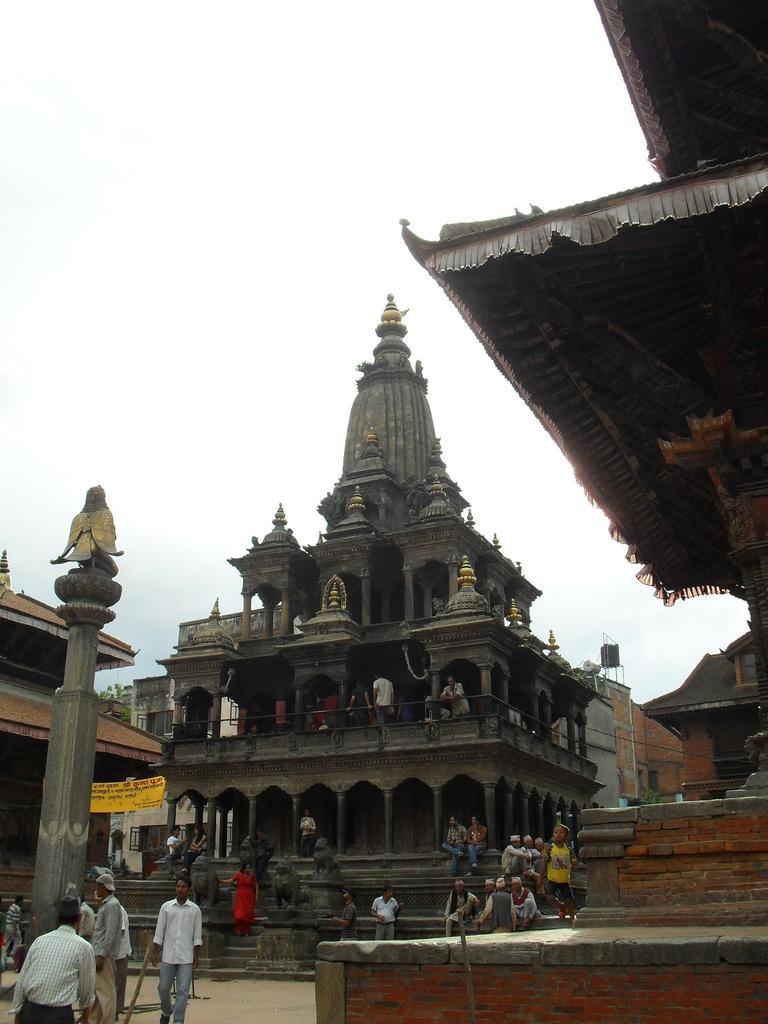Could you give a brief overview of what you see in this image? In this picture there is a temple in the center of the image and there is a pole on the left side of the image and there are people in the center of the image. 